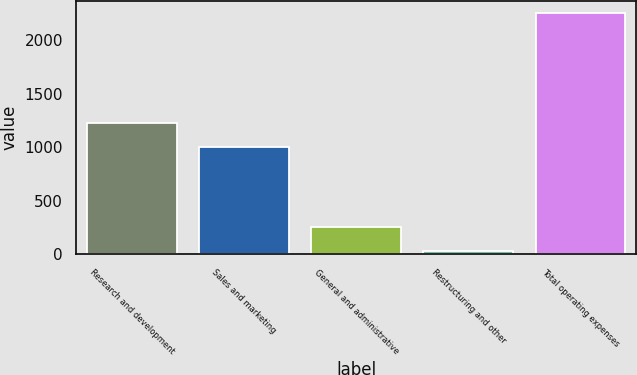<chart> <loc_0><loc_0><loc_500><loc_500><bar_chart><fcel>Research and development<fcel>Sales and marketing<fcel>General and administrative<fcel>Restructuring and other<fcel>Total operating expenses<nl><fcel>1227.15<fcel>1005.2<fcel>252.55<fcel>30.6<fcel>2250.1<nl></chart> 